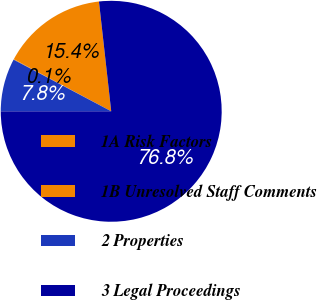Convert chart to OTSL. <chart><loc_0><loc_0><loc_500><loc_500><pie_chart><fcel>1A Risk Factors<fcel>1B Unresolved Staff Comments<fcel>2 Properties<fcel>3 Legal Proceedings<nl><fcel>15.41%<fcel>0.08%<fcel>7.75%<fcel>76.76%<nl></chart> 